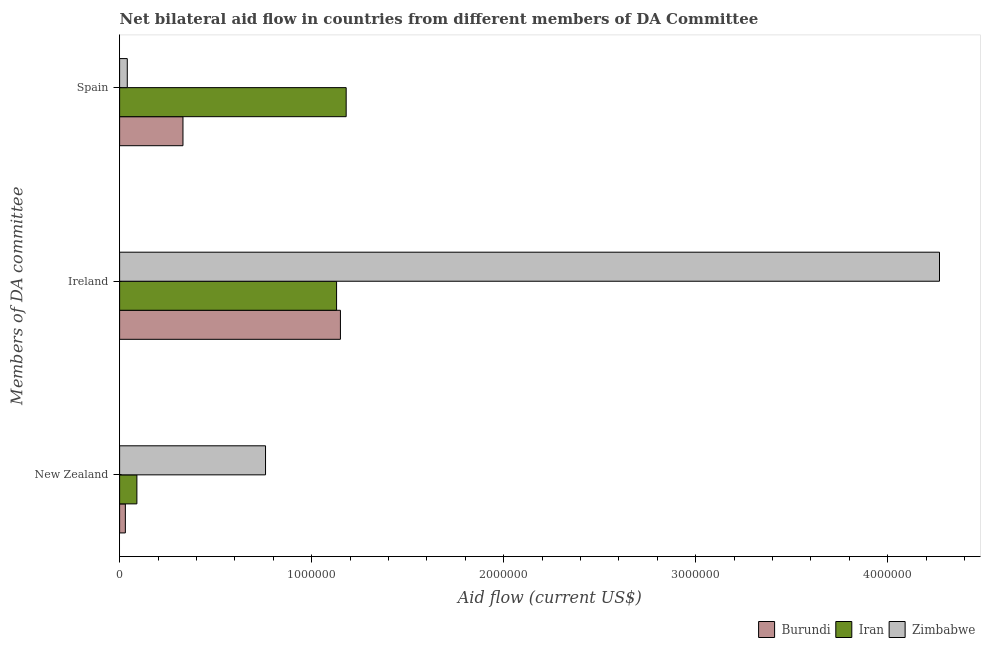How many different coloured bars are there?
Provide a succinct answer. 3. How many groups of bars are there?
Keep it short and to the point. 3. Are the number of bars per tick equal to the number of legend labels?
Keep it short and to the point. Yes. How many bars are there on the 1st tick from the bottom?
Give a very brief answer. 3. What is the label of the 2nd group of bars from the top?
Offer a terse response. Ireland. What is the amount of aid provided by spain in Burundi?
Your answer should be very brief. 3.30e+05. Across all countries, what is the maximum amount of aid provided by new zealand?
Keep it short and to the point. 7.60e+05. Across all countries, what is the minimum amount of aid provided by spain?
Provide a succinct answer. 4.00e+04. In which country was the amount of aid provided by new zealand maximum?
Give a very brief answer. Zimbabwe. In which country was the amount of aid provided by ireland minimum?
Make the answer very short. Iran. What is the total amount of aid provided by spain in the graph?
Provide a short and direct response. 1.55e+06. What is the difference between the amount of aid provided by spain in Burundi and that in Zimbabwe?
Give a very brief answer. 2.90e+05. What is the difference between the amount of aid provided by spain in Iran and the amount of aid provided by ireland in Burundi?
Your response must be concise. 3.00e+04. What is the average amount of aid provided by spain per country?
Keep it short and to the point. 5.17e+05. What is the difference between the amount of aid provided by ireland and amount of aid provided by spain in Iran?
Provide a short and direct response. -5.00e+04. In how many countries, is the amount of aid provided by spain greater than 600000 US$?
Your answer should be very brief. 1. What is the ratio of the amount of aid provided by spain in Burundi to that in Iran?
Provide a short and direct response. 0.28. Is the difference between the amount of aid provided by ireland in Burundi and Iran greater than the difference between the amount of aid provided by spain in Burundi and Iran?
Make the answer very short. Yes. What is the difference between the highest and the second highest amount of aid provided by spain?
Ensure brevity in your answer.  8.50e+05. What is the difference between the highest and the lowest amount of aid provided by new zealand?
Your answer should be compact. 7.30e+05. What does the 1st bar from the top in New Zealand represents?
Offer a terse response. Zimbabwe. What does the 1st bar from the bottom in Ireland represents?
Ensure brevity in your answer.  Burundi. Are all the bars in the graph horizontal?
Offer a very short reply. Yes. What is the difference between two consecutive major ticks on the X-axis?
Give a very brief answer. 1.00e+06. Are the values on the major ticks of X-axis written in scientific E-notation?
Your answer should be very brief. No. Does the graph contain any zero values?
Provide a succinct answer. No. Where does the legend appear in the graph?
Your answer should be compact. Bottom right. How many legend labels are there?
Offer a terse response. 3. What is the title of the graph?
Provide a short and direct response. Net bilateral aid flow in countries from different members of DA Committee. What is the label or title of the X-axis?
Your answer should be compact. Aid flow (current US$). What is the label or title of the Y-axis?
Your answer should be compact. Members of DA committee. What is the Aid flow (current US$) in Burundi in New Zealand?
Provide a short and direct response. 3.00e+04. What is the Aid flow (current US$) in Iran in New Zealand?
Your answer should be very brief. 9.00e+04. What is the Aid flow (current US$) of Zimbabwe in New Zealand?
Offer a very short reply. 7.60e+05. What is the Aid flow (current US$) in Burundi in Ireland?
Offer a terse response. 1.15e+06. What is the Aid flow (current US$) of Iran in Ireland?
Provide a succinct answer. 1.13e+06. What is the Aid flow (current US$) of Zimbabwe in Ireland?
Your response must be concise. 4.27e+06. What is the Aid flow (current US$) of Burundi in Spain?
Keep it short and to the point. 3.30e+05. What is the Aid flow (current US$) in Iran in Spain?
Offer a very short reply. 1.18e+06. Across all Members of DA committee, what is the maximum Aid flow (current US$) in Burundi?
Provide a succinct answer. 1.15e+06. Across all Members of DA committee, what is the maximum Aid flow (current US$) in Iran?
Ensure brevity in your answer.  1.18e+06. Across all Members of DA committee, what is the maximum Aid flow (current US$) of Zimbabwe?
Offer a very short reply. 4.27e+06. What is the total Aid flow (current US$) of Burundi in the graph?
Offer a very short reply. 1.51e+06. What is the total Aid flow (current US$) of Iran in the graph?
Make the answer very short. 2.40e+06. What is the total Aid flow (current US$) of Zimbabwe in the graph?
Provide a succinct answer. 5.07e+06. What is the difference between the Aid flow (current US$) of Burundi in New Zealand and that in Ireland?
Ensure brevity in your answer.  -1.12e+06. What is the difference between the Aid flow (current US$) of Iran in New Zealand and that in Ireland?
Your answer should be very brief. -1.04e+06. What is the difference between the Aid flow (current US$) of Zimbabwe in New Zealand and that in Ireland?
Your answer should be compact. -3.51e+06. What is the difference between the Aid flow (current US$) of Iran in New Zealand and that in Spain?
Your response must be concise. -1.09e+06. What is the difference between the Aid flow (current US$) in Zimbabwe in New Zealand and that in Spain?
Provide a succinct answer. 7.20e+05. What is the difference between the Aid flow (current US$) of Burundi in Ireland and that in Spain?
Your answer should be very brief. 8.20e+05. What is the difference between the Aid flow (current US$) of Zimbabwe in Ireland and that in Spain?
Provide a succinct answer. 4.23e+06. What is the difference between the Aid flow (current US$) in Burundi in New Zealand and the Aid flow (current US$) in Iran in Ireland?
Your answer should be very brief. -1.10e+06. What is the difference between the Aid flow (current US$) in Burundi in New Zealand and the Aid flow (current US$) in Zimbabwe in Ireland?
Provide a succinct answer. -4.24e+06. What is the difference between the Aid flow (current US$) of Iran in New Zealand and the Aid flow (current US$) of Zimbabwe in Ireland?
Provide a succinct answer. -4.18e+06. What is the difference between the Aid flow (current US$) in Burundi in New Zealand and the Aid flow (current US$) in Iran in Spain?
Make the answer very short. -1.15e+06. What is the difference between the Aid flow (current US$) of Iran in New Zealand and the Aid flow (current US$) of Zimbabwe in Spain?
Provide a succinct answer. 5.00e+04. What is the difference between the Aid flow (current US$) in Burundi in Ireland and the Aid flow (current US$) in Iran in Spain?
Offer a terse response. -3.00e+04. What is the difference between the Aid flow (current US$) in Burundi in Ireland and the Aid flow (current US$) in Zimbabwe in Spain?
Give a very brief answer. 1.11e+06. What is the difference between the Aid flow (current US$) of Iran in Ireland and the Aid flow (current US$) of Zimbabwe in Spain?
Ensure brevity in your answer.  1.09e+06. What is the average Aid flow (current US$) of Burundi per Members of DA committee?
Provide a short and direct response. 5.03e+05. What is the average Aid flow (current US$) in Zimbabwe per Members of DA committee?
Give a very brief answer. 1.69e+06. What is the difference between the Aid flow (current US$) of Burundi and Aid flow (current US$) of Iran in New Zealand?
Your answer should be very brief. -6.00e+04. What is the difference between the Aid flow (current US$) in Burundi and Aid flow (current US$) in Zimbabwe in New Zealand?
Keep it short and to the point. -7.30e+05. What is the difference between the Aid flow (current US$) of Iran and Aid flow (current US$) of Zimbabwe in New Zealand?
Ensure brevity in your answer.  -6.70e+05. What is the difference between the Aid flow (current US$) of Burundi and Aid flow (current US$) of Zimbabwe in Ireland?
Provide a short and direct response. -3.12e+06. What is the difference between the Aid flow (current US$) of Iran and Aid flow (current US$) of Zimbabwe in Ireland?
Your response must be concise. -3.14e+06. What is the difference between the Aid flow (current US$) in Burundi and Aid flow (current US$) in Iran in Spain?
Provide a short and direct response. -8.50e+05. What is the difference between the Aid flow (current US$) of Iran and Aid flow (current US$) of Zimbabwe in Spain?
Offer a very short reply. 1.14e+06. What is the ratio of the Aid flow (current US$) of Burundi in New Zealand to that in Ireland?
Your answer should be compact. 0.03. What is the ratio of the Aid flow (current US$) in Iran in New Zealand to that in Ireland?
Offer a very short reply. 0.08. What is the ratio of the Aid flow (current US$) of Zimbabwe in New Zealand to that in Ireland?
Provide a short and direct response. 0.18. What is the ratio of the Aid flow (current US$) in Burundi in New Zealand to that in Spain?
Offer a very short reply. 0.09. What is the ratio of the Aid flow (current US$) in Iran in New Zealand to that in Spain?
Offer a very short reply. 0.08. What is the ratio of the Aid flow (current US$) of Zimbabwe in New Zealand to that in Spain?
Provide a short and direct response. 19. What is the ratio of the Aid flow (current US$) of Burundi in Ireland to that in Spain?
Your answer should be compact. 3.48. What is the ratio of the Aid flow (current US$) of Iran in Ireland to that in Spain?
Provide a short and direct response. 0.96. What is the ratio of the Aid flow (current US$) of Zimbabwe in Ireland to that in Spain?
Offer a very short reply. 106.75. What is the difference between the highest and the second highest Aid flow (current US$) in Burundi?
Make the answer very short. 8.20e+05. What is the difference between the highest and the second highest Aid flow (current US$) of Zimbabwe?
Offer a terse response. 3.51e+06. What is the difference between the highest and the lowest Aid flow (current US$) in Burundi?
Keep it short and to the point. 1.12e+06. What is the difference between the highest and the lowest Aid flow (current US$) in Iran?
Provide a short and direct response. 1.09e+06. What is the difference between the highest and the lowest Aid flow (current US$) in Zimbabwe?
Offer a terse response. 4.23e+06. 